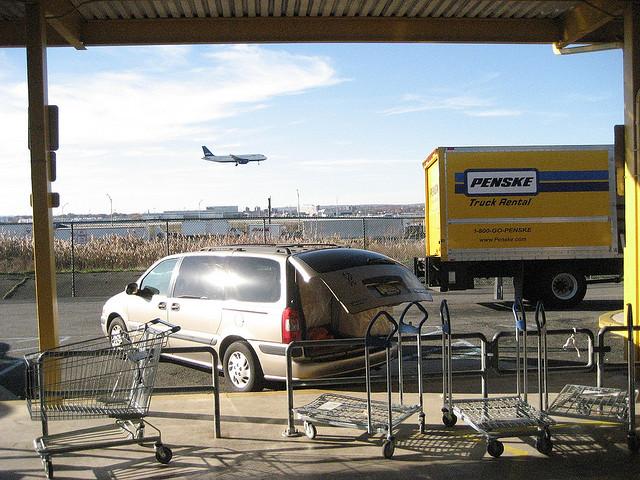Is the airplane in the background in the air or on the ground?
Short answer required. Air. IS the trunk open?
Short answer required. Yes. What type of truck is on the road?
Keep it brief. Moving truck. Is this in the United States?
Answer briefly. Yes. 